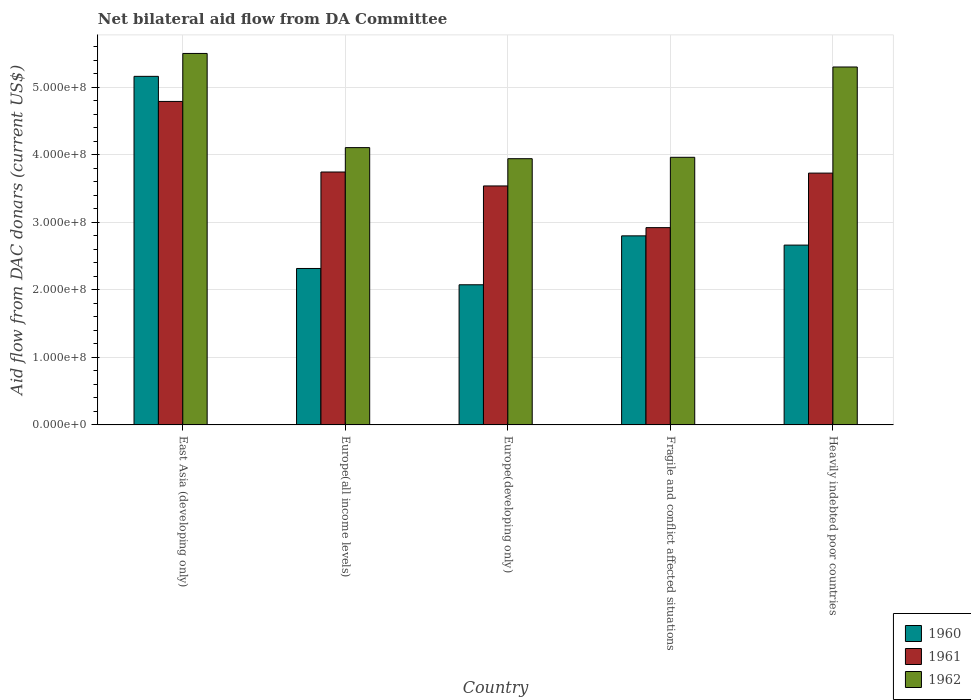How many different coloured bars are there?
Provide a succinct answer. 3. How many groups of bars are there?
Your response must be concise. 5. Are the number of bars per tick equal to the number of legend labels?
Make the answer very short. Yes. Are the number of bars on each tick of the X-axis equal?
Give a very brief answer. Yes. What is the label of the 4th group of bars from the left?
Give a very brief answer. Fragile and conflict affected situations. In how many cases, is the number of bars for a given country not equal to the number of legend labels?
Ensure brevity in your answer.  0. What is the aid flow in in 1961 in Europe(all income levels)?
Make the answer very short. 3.74e+08. Across all countries, what is the maximum aid flow in in 1962?
Ensure brevity in your answer.  5.50e+08. Across all countries, what is the minimum aid flow in in 1962?
Your response must be concise. 3.94e+08. In which country was the aid flow in in 1960 maximum?
Your answer should be compact. East Asia (developing only). In which country was the aid flow in in 1962 minimum?
Your response must be concise. Europe(developing only). What is the total aid flow in in 1961 in the graph?
Offer a terse response. 1.87e+09. What is the difference between the aid flow in in 1961 in Europe(developing only) and that in Heavily indebted poor countries?
Your answer should be very brief. -1.90e+07. What is the difference between the aid flow in in 1962 in Europe(all income levels) and the aid flow in in 1960 in Europe(developing only)?
Give a very brief answer. 2.03e+08. What is the average aid flow in in 1962 per country?
Give a very brief answer. 4.56e+08. What is the difference between the aid flow in of/in 1960 and aid flow in of/in 1961 in Heavily indebted poor countries?
Your response must be concise. -1.07e+08. In how many countries, is the aid flow in in 1962 greater than 540000000 US$?
Keep it short and to the point. 1. What is the ratio of the aid flow in in 1960 in East Asia (developing only) to that in Europe(all income levels)?
Make the answer very short. 2.23. Is the aid flow in in 1961 in East Asia (developing only) less than that in Europe(all income levels)?
Your response must be concise. No. Is the difference between the aid flow in in 1960 in Europe(developing only) and Fragile and conflict affected situations greater than the difference between the aid flow in in 1961 in Europe(developing only) and Fragile and conflict affected situations?
Your response must be concise. No. What is the difference between the highest and the second highest aid flow in in 1960?
Keep it short and to the point. 2.50e+08. What is the difference between the highest and the lowest aid flow in in 1962?
Ensure brevity in your answer.  1.56e+08. In how many countries, is the aid flow in in 1961 greater than the average aid flow in in 1961 taken over all countries?
Your answer should be compact. 2. Is the sum of the aid flow in in 1961 in East Asia (developing only) and Europe(all income levels) greater than the maximum aid flow in in 1962 across all countries?
Offer a terse response. Yes. What does the 1st bar from the right in Europe(all income levels) represents?
Give a very brief answer. 1962. How many bars are there?
Offer a very short reply. 15. How many countries are there in the graph?
Make the answer very short. 5. What is the difference between two consecutive major ticks on the Y-axis?
Your answer should be very brief. 1.00e+08. Are the values on the major ticks of Y-axis written in scientific E-notation?
Ensure brevity in your answer.  Yes. Where does the legend appear in the graph?
Your answer should be compact. Bottom right. How many legend labels are there?
Provide a succinct answer. 3. How are the legend labels stacked?
Your answer should be compact. Vertical. What is the title of the graph?
Give a very brief answer. Net bilateral aid flow from DA Committee. Does "1986" appear as one of the legend labels in the graph?
Your answer should be compact. No. What is the label or title of the Y-axis?
Provide a succinct answer. Aid flow from DAC donars (current US$). What is the Aid flow from DAC donars (current US$) in 1960 in East Asia (developing only)?
Ensure brevity in your answer.  5.16e+08. What is the Aid flow from DAC donars (current US$) in 1961 in East Asia (developing only)?
Your answer should be compact. 4.79e+08. What is the Aid flow from DAC donars (current US$) of 1962 in East Asia (developing only)?
Give a very brief answer. 5.50e+08. What is the Aid flow from DAC donars (current US$) in 1960 in Europe(all income levels)?
Your response must be concise. 2.32e+08. What is the Aid flow from DAC donars (current US$) in 1961 in Europe(all income levels)?
Offer a terse response. 3.74e+08. What is the Aid flow from DAC donars (current US$) of 1962 in Europe(all income levels)?
Make the answer very short. 4.11e+08. What is the Aid flow from DAC donars (current US$) of 1960 in Europe(developing only)?
Make the answer very short. 2.08e+08. What is the Aid flow from DAC donars (current US$) in 1961 in Europe(developing only)?
Give a very brief answer. 3.54e+08. What is the Aid flow from DAC donars (current US$) in 1962 in Europe(developing only)?
Keep it short and to the point. 3.94e+08. What is the Aid flow from DAC donars (current US$) of 1960 in Fragile and conflict affected situations?
Provide a succinct answer. 2.80e+08. What is the Aid flow from DAC donars (current US$) of 1961 in Fragile and conflict affected situations?
Ensure brevity in your answer.  2.92e+08. What is the Aid flow from DAC donars (current US$) in 1962 in Fragile and conflict affected situations?
Keep it short and to the point. 3.96e+08. What is the Aid flow from DAC donars (current US$) of 1960 in Heavily indebted poor countries?
Make the answer very short. 2.66e+08. What is the Aid flow from DAC donars (current US$) of 1961 in Heavily indebted poor countries?
Offer a very short reply. 3.73e+08. What is the Aid flow from DAC donars (current US$) of 1962 in Heavily indebted poor countries?
Offer a terse response. 5.30e+08. Across all countries, what is the maximum Aid flow from DAC donars (current US$) in 1960?
Your answer should be very brief. 5.16e+08. Across all countries, what is the maximum Aid flow from DAC donars (current US$) of 1961?
Offer a very short reply. 4.79e+08. Across all countries, what is the maximum Aid flow from DAC donars (current US$) of 1962?
Keep it short and to the point. 5.50e+08. Across all countries, what is the minimum Aid flow from DAC donars (current US$) of 1960?
Offer a terse response. 2.08e+08. Across all countries, what is the minimum Aid flow from DAC donars (current US$) of 1961?
Offer a very short reply. 2.92e+08. Across all countries, what is the minimum Aid flow from DAC donars (current US$) in 1962?
Offer a terse response. 3.94e+08. What is the total Aid flow from DAC donars (current US$) in 1960 in the graph?
Ensure brevity in your answer.  1.50e+09. What is the total Aid flow from DAC donars (current US$) in 1961 in the graph?
Provide a short and direct response. 1.87e+09. What is the total Aid flow from DAC donars (current US$) in 1962 in the graph?
Offer a very short reply. 2.28e+09. What is the difference between the Aid flow from DAC donars (current US$) in 1960 in East Asia (developing only) and that in Europe(all income levels)?
Your answer should be very brief. 2.84e+08. What is the difference between the Aid flow from DAC donars (current US$) of 1961 in East Asia (developing only) and that in Europe(all income levels)?
Provide a short and direct response. 1.05e+08. What is the difference between the Aid flow from DAC donars (current US$) of 1962 in East Asia (developing only) and that in Europe(all income levels)?
Offer a terse response. 1.39e+08. What is the difference between the Aid flow from DAC donars (current US$) in 1960 in East Asia (developing only) and that in Europe(developing only)?
Offer a terse response. 3.09e+08. What is the difference between the Aid flow from DAC donars (current US$) of 1961 in East Asia (developing only) and that in Europe(developing only)?
Provide a succinct answer. 1.25e+08. What is the difference between the Aid flow from DAC donars (current US$) in 1962 in East Asia (developing only) and that in Europe(developing only)?
Provide a succinct answer. 1.56e+08. What is the difference between the Aid flow from DAC donars (current US$) in 1960 in East Asia (developing only) and that in Fragile and conflict affected situations?
Keep it short and to the point. 2.36e+08. What is the difference between the Aid flow from DAC donars (current US$) of 1961 in East Asia (developing only) and that in Fragile and conflict affected situations?
Your answer should be compact. 1.87e+08. What is the difference between the Aid flow from DAC donars (current US$) in 1962 in East Asia (developing only) and that in Fragile and conflict affected situations?
Provide a succinct answer. 1.54e+08. What is the difference between the Aid flow from DAC donars (current US$) in 1960 in East Asia (developing only) and that in Heavily indebted poor countries?
Provide a succinct answer. 2.50e+08. What is the difference between the Aid flow from DAC donars (current US$) in 1961 in East Asia (developing only) and that in Heavily indebted poor countries?
Give a very brief answer. 1.06e+08. What is the difference between the Aid flow from DAC donars (current US$) in 1962 in East Asia (developing only) and that in Heavily indebted poor countries?
Provide a succinct answer. 2.01e+07. What is the difference between the Aid flow from DAC donars (current US$) in 1960 in Europe(all income levels) and that in Europe(developing only)?
Your answer should be compact. 2.41e+07. What is the difference between the Aid flow from DAC donars (current US$) in 1961 in Europe(all income levels) and that in Europe(developing only)?
Your response must be concise. 2.06e+07. What is the difference between the Aid flow from DAC donars (current US$) in 1962 in Europe(all income levels) and that in Europe(developing only)?
Offer a very short reply. 1.64e+07. What is the difference between the Aid flow from DAC donars (current US$) in 1960 in Europe(all income levels) and that in Fragile and conflict affected situations?
Your answer should be very brief. -4.83e+07. What is the difference between the Aid flow from DAC donars (current US$) in 1961 in Europe(all income levels) and that in Fragile and conflict affected situations?
Ensure brevity in your answer.  8.24e+07. What is the difference between the Aid flow from DAC donars (current US$) of 1962 in Europe(all income levels) and that in Fragile and conflict affected situations?
Your response must be concise. 1.44e+07. What is the difference between the Aid flow from DAC donars (current US$) in 1960 in Europe(all income levels) and that in Heavily indebted poor countries?
Give a very brief answer. -3.46e+07. What is the difference between the Aid flow from DAC donars (current US$) in 1961 in Europe(all income levels) and that in Heavily indebted poor countries?
Give a very brief answer. 1.61e+06. What is the difference between the Aid flow from DAC donars (current US$) of 1962 in Europe(all income levels) and that in Heavily indebted poor countries?
Your answer should be compact. -1.19e+08. What is the difference between the Aid flow from DAC donars (current US$) of 1960 in Europe(developing only) and that in Fragile and conflict affected situations?
Your response must be concise. -7.24e+07. What is the difference between the Aid flow from DAC donars (current US$) of 1961 in Europe(developing only) and that in Fragile and conflict affected situations?
Your response must be concise. 6.17e+07. What is the difference between the Aid flow from DAC donars (current US$) of 1962 in Europe(developing only) and that in Fragile and conflict affected situations?
Give a very brief answer. -2.05e+06. What is the difference between the Aid flow from DAC donars (current US$) of 1960 in Europe(developing only) and that in Heavily indebted poor countries?
Provide a succinct answer. -5.87e+07. What is the difference between the Aid flow from DAC donars (current US$) in 1961 in Europe(developing only) and that in Heavily indebted poor countries?
Give a very brief answer. -1.90e+07. What is the difference between the Aid flow from DAC donars (current US$) of 1962 in Europe(developing only) and that in Heavily indebted poor countries?
Give a very brief answer. -1.36e+08. What is the difference between the Aid flow from DAC donars (current US$) of 1960 in Fragile and conflict affected situations and that in Heavily indebted poor countries?
Make the answer very short. 1.37e+07. What is the difference between the Aid flow from DAC donars (current US$) in 1961 in Fragile and conflict affected situations and that in Heavily indebted poor countries?
Your answer should be very brief. -8.08e+07. What is the difference between the Aid flow from DAC donars (current US$) of 1962 in Fragile and conflict affected situations and that in Heavily indebted poor countries?
Give a very brief answer. -1.34e+08. What is the difference between the Aid flow from DAC donars (current US$) of 1960 in East Asia (developing only) and the Aid flow from DAC donars (current US$) of 1961 in Europe(all income levels)?
Provide a short and direct response. 1.42e+08. What is the difference between the Aid flow from DAC donars (current US$) in 1960 in East Asia (developing only) and the Aid flow from DAC donars (current US$) in 1962 in Europe(all income levels)?
Offer a very short reply. 1.06e+08. What is the difference between the Aid flow from DAC donars (current US$) of 1961 in East Asia (developing only) and the Aid flow from DAC donars (current US$) of 1962 in Europe(all income levels)?
Give a very brief answer. 6.84e+07. What is the difference between the Aid flow from DAC donars (current US$) in 1960 in East Asia (developing only) and the Aid flow from DAC donars (current US$) in 1961 in Europe(developing only)?
Your response must be concise. 1.62e+08. What is the difference between the Aid flow from DAC donars (current US$) in 1960 in East Asia (developing only) and the Aid flow from DAC donars (current US$) in 1962 in Europe(developing only)?
Your response must be concise. 1.22e+08. What is the difference between the Aid flow from DAC donars (current US$) in 1961 in East Asia (developing only) and the Aid flow from DAC donars (current US$) in 1962 in Europe(developing only)?
Offer a terse response. 8.48e+07. What is the difference between the Aid flow from DAC donars (current US$) of 1960 in East Asia (developing only) and the Aid flow from DAC donars (current US$) of 1961 in Fragile and conflict affected situations?
Offer a very short reply. 2.24e+08. What is the difference between the Aid flow from DAC donars (current US$) of 1960 in East Asia (developing only) and the Aid flow from DAC donars (current US$) of 1962 in Fragile and conflict affected situations?
Provide a succinct answer. 1.20e+08. What is the difference between the Aid flow from DAC donars (current US$) of 1961 in East Asia (developing only) and the Aid flow from DAC donars (current US$) of 1962 in Fragile and conflict affected situations?
Provide a succinct answer. 8.28e+07. What is the difference between the Aid flow from DAC donars (current US$) in 1960 in East Asia (developing only) and the Aid flow from DAC donars (current US$) in 1961 in Heavily indebted poor countries?
Offer a very short reply. 1.43e+08. What is the difference between the Aid flow from DAC donars (current US$) of 1960 in East Asia (developing only) and the Aid flow from DAC donars (current US$) of 1962 in Heavily indebted poor countries?
Offer a terse response. -1.39e+07. What is the difference between the Aid flow from DAC donars (current US$) of 1961 in East Asia (developing only) and the Aid flow from DAC donars (current US$) of 1962 in Heavily indebted poor countries?
Offer a very short reply. -5.10e+07. What is the difference between the Aid flow from DAC donars (current US$) of 1960 in Europe(all income levels) and the Aid flow from DAC donars (current US$) of 1961 in Europe(developing only)?
Offer a very short reply. -1.22e+08. What is the difference between the Aid flow from DAC donars (current US$) of 1960 in Europe(all income levels) and the Aid flow from DAC donars (current US$) of 1962 in Europe(developing only)?
Provide a short and direct response. -1.63e+08. What is the difference between the Aid flow from DAC donars (current US$) in 1961 in Europe(all income levels) and the Aid flow from DAC donars (current US$) in 1962 in Europe(developing only)?
Offer a terse response. -1.97e+07. What is the difference between the Aid flow from DAC donars (current US$) in 1960 in Europe(all income levels) and the Aid flow from DAC donars (current US$) in 1961 in Fragile and conflict affected situations?
Provide a short and direct response. -6.05e+07. What is the difference between the Aid flow from DAC donars (current US$) in 1960 in Europe(all income levels) and the Aid flow from DAC donars (current US$) in 1962 in Fragile and conflict affected situations?
Provide a succinct answer. -1.65e+08. What is the difference between the Aid flow from DAC donars (current US$) of 1961 in Europe(all income levels) and the Aid flow from DAC donars (current US$) of 1962 in Fragile and conflict affected situations?
Offer a terse response. -2.18e+07. What is the difference between the Aid flow from DAC donars (current US$) in 1960 in Europe(all income levels) and the Aid flow from DAC donars (current US$) in 1961 in Heavily indebted poor countries?
Make the answer very short. -1.41e+08. What is the difference between the Aid flow from DAC donars (current US$) in 1960 in Europe(all income levels) and the Aid flow from DAC donars (current US$) in 1962 in Heavily indebted poor countries?
Offer a terse response. -2.98e+08. What is the difference between the Aid flow from DAC donars (current US$) of 1961 in Europe(all income levels) and the Aid flow from DAC donars (current US$) of 1962 in Heavily indebted poor countries?
Provide a succinct answer. -1.56e+08. What is the difference between the Aid flow from DAC donars (current US$) of 1960 in Europe(developing only) and the Aid flow from DAC donars (current US$) of 1961 in Fragile and conflict affected situations?
Ensure brevity in your answer.  -8.46e+07. What is the difference between the Aid flow from DAC donars (current US$) in 1960 in Europe(developing only) and the Aid flow from DAC donars (current US$) in 1962 in Fragile and conflict affected situations?
Ensure brevity in your answer.  -1.89e+08. What is the difference between the Aid flow from DAC donars (current US$) in 1961 in Europe(developing only) and the Aid flow from DAC donars (current US$) in 1962 in Fragile and conflict affected situations?
Give a very brief answer. -4.24e+07. What is the difference between the Aid flow from DAC donars (current US$) of 1960 in Europe(developing only) and the Aid flow from DAC donars (current US$) of 1961 in Heavily indebted poor countries?
Your response must be concise. -1.65e+08. What is the difference between the Aid flow from DAC donars (current US$) in 1960 in Europe(developing only) and the Aid flow from DAC donars (current US$) in 1962 in Heavily indebted poor countries?
Ensure brevity in your answer.  -3.22e+08. What is the difference between the Aid flow from DAC donars (current US$) in 1961 in Europe(developing only) and the Aid flow from DAC donars (current US$) in 1962 in Heavily indebted poor countries?
Your answer should be very brief. -1.76e+08. What is the difference between the Aid flow from DAC donars (current US$) in 1960 in Fragile and conflict affected situations and the Aid flow from DAC donars (current US$) in 1961 in Heavily indebted poor countries?
Your response must be concise. -9.29e+07. What is the difference between the Aid flow from DAC donars (current US$) in 1960 in Fragile and conflict affected situations and the Aid flow from DAC donars (current US$) in 1962 in Heavily indebted poor countries?
Provide a succinct answer. -2.50e+08. What is the difference between the Aid flow from DAC donars (current US$) in 1961 in Fragile and conflict affected situations and the Aid flow from DAC donars (current US$) in 1962 in Heavily indebted poor countries?
Your answer should be very brief. -2.38e+08. What is the average Aid flow from DAC donars (current US$) in 1960 per country?
Provide a succinct answer. 3.00e+08. What is the average Aid flow from DAC donars (current US$) of 1961 per country?
Make the answer very short. 3.74e+08. What is the average Aid flow from DAC donars (current US$) in 1962 per country?
Provide a succinct answer. 4.56e+08. What is the difference between the Aid flow from DAC donars (current US$) of 1960 and Aid flow from DAC donars (current US$) of 1961 in East Asia (developing only)?
Ensure brevity in your answer.  3.71e+07. What is the difference between the Aid flow from DAC donars (current US$) of 1960 and Aid flow from DAC donars (current US$) of 1962 in East Asia (developing only)?
Provide a succinct answer. -3.39e+07. What is the difference between the Aid flow from DAC donars (current US$) in 1961 and Aid flow from DAC donars (current US$) in 1962 in East Asia (developing only)?
Give a very brief answer. -7.10e+07. What is the difference between the Aid flow from DAC donars (current US$) in 1960 and Aid flow from DAC donars (current US$) in 1961 in Europe(all income levels)?
Offer a terse response. -1.43e+08. What is the difference between the Aid flow from DAC donars (current US$) of 1960 and Aid flow from DAC donars (current US$) of 1962 in Europe(all income levels)?
Provide a succinct answer. -1.79e+08. What is the difference between the Aid flow from DAC donars (current US$) in 1961 and Aid flow from DAC donars (current US$) in 1962 in Europe(all income levels)?
Your answer should be compact. -3.61e+07. What is the difference between the Aid flow from DAC donars (current US$) of 1960 and Aid flow from DAC donars (current US$) of 1961 in Europe(developing only)?
Provide a short and direct response. -1.46e+08. What is the difference between the Aid flow from DAC donars (current US$) of 1960 and Aid flow from DAC donars (current US$) of 1962 in Europe(developing only)?
Your answer should be very brief. -1.87e+08. What is the difference between the Aid flow from DAC donars (current US$) in 1961 and Aid flow from DAC donars (current US$) in 1962 in Europe(developing only)?
Your answer should be very brief. -4.04e+07. What is the difference between the Aid flow from DAC donars (current US$) in 1960 and Aid flow from DAC donars (current US$) in 1961 in Fragile and conflict affected situations?
Ensure brevity in your answer.  -1.22e+07. What is the difference between the Aid flow from DAC donars (current US$) of 1960 and Aid flow from DAC donars (current US$) of 1962 in Fragile and conflict affected situations?
Offer a very short reply. -1.16e+08. What is the difference between the Aid flow from DAC donars (current US$) of 1961 and Aid flow from DAC donars (current US$) of 1962 in Fragile and conflict affected situations?
Make the answer very short. -1.04e+08. What is the difference between the Aid flow from DAC donars (current US$) in 1960 and Aid flow from DAC donars (current US$) in 1961 in Heavily indebted poor countries?
Your response must be concise. -1.07e+08. What is the difference between the Aid flow from DAC donars (current US$) in 1960 and Aid flow from DAC donars (current US$) in 1962 in Heavily indebted poor countries?
Keep it short and to the point. -2.64e+08. What is the difference between the Aid flow from DAC donars (current US$) of 1961 and Aid flow from DAC donars (current US$) of 1962 in Heavily indebted poor countries?
Offer a very short reply. -1.57e+08. What is the ratio of the Aid flow from DAC donars (current US$) of 1960 in East Asia (developing only) to that in Europe(all income levels)?
Provide a succinct answer. 2.23. What is the ratio of the Aid flow from DAC donars (current US$) of 1961 in East Asia (developing only) to that in Europe(all income levels)?
Make the answer very short. 1.28. What is the ratio of the Aid flow from DAC donars (current US$) of 1962 in East Asia (developing only) to that in Europe(all income levels)?
Offer a terse response. 1.34. What is the ratio of the Aid flow from DAC donars (current US$) of 1960 in East Asia (developing only) to that in Europe(developing only)?
Offer a terse response. 2.49. What is the ratio of the Aid flow from DAC donars (current US$) of 1961 in East Asia (developing only) to that in Europe(developing only)?
Your answer should be compact. 1.35. What is the ratio of the Aid flow from DAC donars (current US$) of 1962 in East Asia (developing only) to that in Europe(developing only)?
Provide a short and direct response. 1.4. What is the ratio of the Aid flow from DAC donars (current US$) of 1960 in East Asia (developing only) to that in Fragile and conflict affected situations?
Keep it short and to the point. 1.84. What is the ratio of the Aid flow from DAC donars (current US$) in 1961 in East Asia (developing only) to that in Fragile and conflict affected situations?
Make the answer very short. 1.64. What is the ratio of the Aid flow from DAC donars (current US$) of 1962 in East Asia (developing only) to that in Fragile and conflict affected situations?
Give a very brief answer. 1.39. What is the ratio of the Aid flow from DAC donars (current US$) of 1960 in East Asia (developing only) to that in Heavily indebted poor countries?
Your response must be concise. 1.94. What is the ratio of the Aid flow from DAC donars (current US$) of 1961 in East Asia (developing only) to that in Heavily indebted poor countries?
Your answer should be compact. 1.28. What is the ratio of the Aid flow from DAC donars (current US$) of 1962 in East Asia (developing only) to that in Heavily indebted poor countries?
Ensure brevity in your answer.  1.04. What is the ratio of the Aid flow from DAC donars (current US$) in 1960 in Europe(all income levels) to that in Europe(developing only)?
Your answer should be compact. 1.12. What is the ratio of the Aid flow from DAC donars (current US$) in 1961 in Europe(all income levels) to that in Europe(developing only)?
Offer a very short reply. 1.06. What is the ratio of the Aid flow from DAC donars (current US$) in 1962 in Europe(all income levels) to that in Europe(developing only)?
Keep it short and to the point. 1.04. What is the ratio of the Aid flow from DAC donars (current US$) of 1960 in Europe(all income levels) to that in Fragile and conflict affected situations?
Your response must be concise. 0.83. What is the ratio of the Aid flow from DAC donars (current US$) of 1961 in Europe(all income levels) to that in Fragile and conflict affected situations?
Your answer should be very brief. 1.28. What is the ratio of the Aid flow from DAC donars (current US$) in 1962 in Europe(all income levels) to that in Fragile and conflict affected situations?
Offer a very short reply. 1.04. What is the ratio of the Aid flow from DAC donars (current US$) of 1960 in Europe(all income levels) to that in Heavily indebted poor countries?
Offer a terse response. 0.87. What is the ratio of the Aid flow from DAC donars (current US$) in 1961 in Europe(all income levels) to that in Heavily indebted poor countries?
Offer a very short reply. 1. What is the ratio of the Aid flow from DAC donars (current US$) in 1962 in Europe(all income levels) to that in Heavily indebted poor countries?
Ensure brevity in your answer.  0.77. What is the ratio of the Aid flow from DAC donars (current US$) of 1960 in Europe(developing only) to that in Fragile and conflict affected situations?
Give a very brief answer. 0.74. What is the ratio of the Aid flow from DAC donars (current US$) in 1961 in Europe(developing only) to that in Fragile and conflict affected situations?
Give a very brief answer. 1.21. What is the ratio of the Aid flow from DAC donars (current US$) of 1960 in Europe(developing only) to that in Heavily indebted poor countries?
Offer a terse response. 0.78. What is the ratio of the Aid flow from DAC donars (current US$) in 1961 in Europe(developing only) to that in Heavily indebted poor countries?
Provide a succinct answer. 0.95. What is the ratio of the Aid flow from DAC donars (current US$) in 1962 in Europe(developing only) to that in Heavily indebted poor countries?
Ensure brevity in your answer.  0.74. What is the ratio of the Aid flow from DAC donars (current US$) in 1960 in Fragile and conflict affected situations to that in Heavily indebted poor countries?
Give a very brief answer. 1.05. What is the ratio of the Aid flow from DAC donars (current US$) of 1961 in Fragile and conflict affected situations to that in Heavily indebted poor countries?
Provide a short and direct response. 0.78. What is the ratio of the Aid flow from DAC donars (current US$) in 1962 in Fragile and conflict affected situations to that in Heavily indebted poor countries?
Keep it short and to the point. 0.75. What is the difference between the highest and the second highest Aid flow from DAC donars (current US$) of 1960?
Ensure brevity in your answer.  2.36e+08. What is the difference between the highest and the second highest Aid flow from DAC donars (current US$) in 1961?
Your answer should be compact. 1.05e+08. What is the difference between the highest and the second highest Aid flow from DAC donars (current US$) in 1962?
Your answer should be very brief. 2.01e+07. What is the difference between the highest and the lowest Aid flow from DAC donars (current US$) in 1960?
Provide a short and direct response. 3.09e+08. What is the difference between the highest and the lowest Aid flow from DAC donars (current US$) in 1961?
Give a very brief answer. 1.87e+08. What is the difference between the highest and the lowest Aid flow from DAC donars (current US$) in 1962?
Make the answer very short. 1.56e+08. 